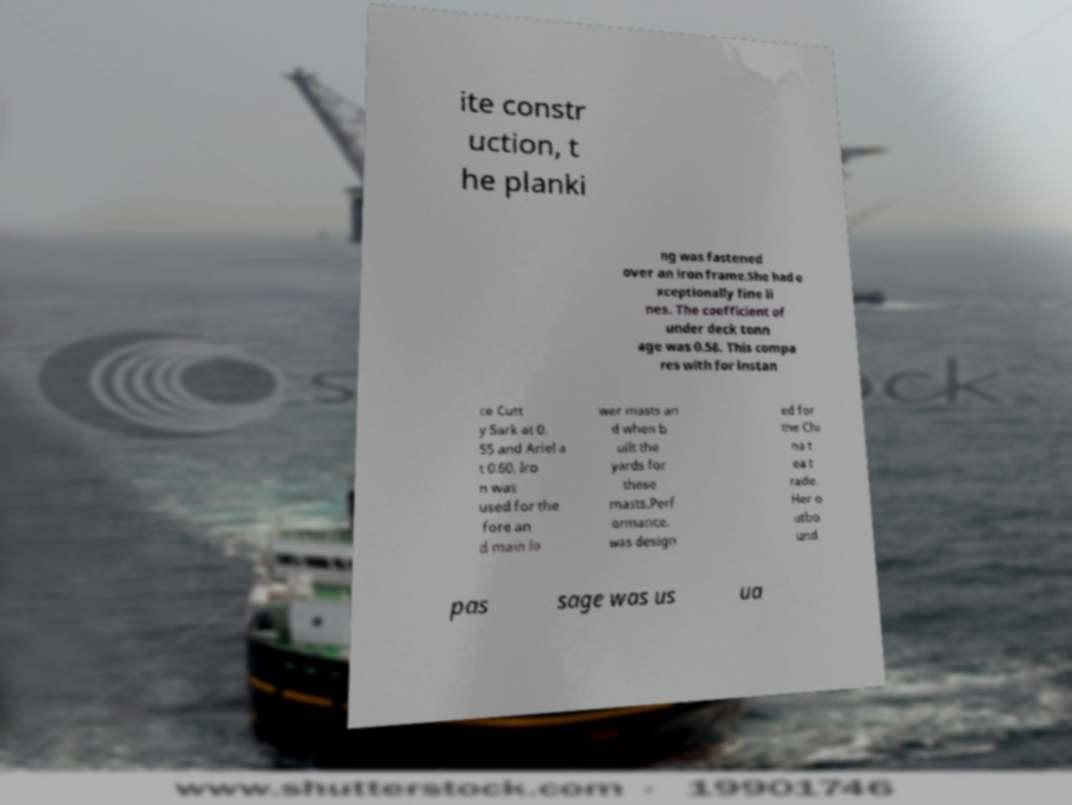For documentation purposes, I need the text within this image transcribed. Could you provide that? ite constr uction, t he planki ng was fastened over an iron frame.She had e xceptionally fine li nes. The coefficient of under deck tonn age was 0.58. This compa res with for instan ce Cutt y Sark at 0. 55 and Ariel a t 0.60. Iro n was used for the fore an d main lo wer masts an d when b uilt the yards for these masts.Perf ormance. was design ed for the Chi na t ea t rade. Her o utbo und pas sage was us ua 